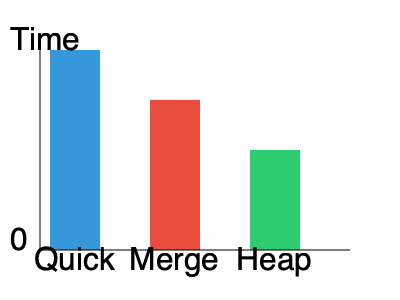Based on the bar graph comparing the efficiency of different sorting algorithms, which algorithm appears to be the most time-efficient for the given dataset? To determine the most time-efficient algorithm, we need to analyze the bar heights in the graph, as they represent the time taken by each algorithm:

1. The bar heights represent the execution time for each algorithm.
2. A shorter bar indicates less time taken, thus higher efficiency.
3. The algorithms presented are Quick Sort, Merge Sort, and Heap Sort.
4. Quick Sort (blue) has the tallest bar, indicating it took the most time.
5. Merge Sort (red) has a medium-height bar, showing it was faster than Quick Sort.
6. Heap Sort (green) has the shortest bar, representing the least time taken.

Therefore, based on the visual representation, Heap Sort appears to be the most time-efficient algorithm for this particular dataset.

It's important to note that:
a) Algorithm efficiency can vary depending on the specific dataset and its characteristics.
b) The graph represents a single case and may not reflect the average-case or worst-case scenarios.
c) In practice, the choice of sorting algorithm often depends on various factors beyond just time efficiency, such as space complexity, stability, and the nature of the data being sorted.
Answer: Heap Sort 